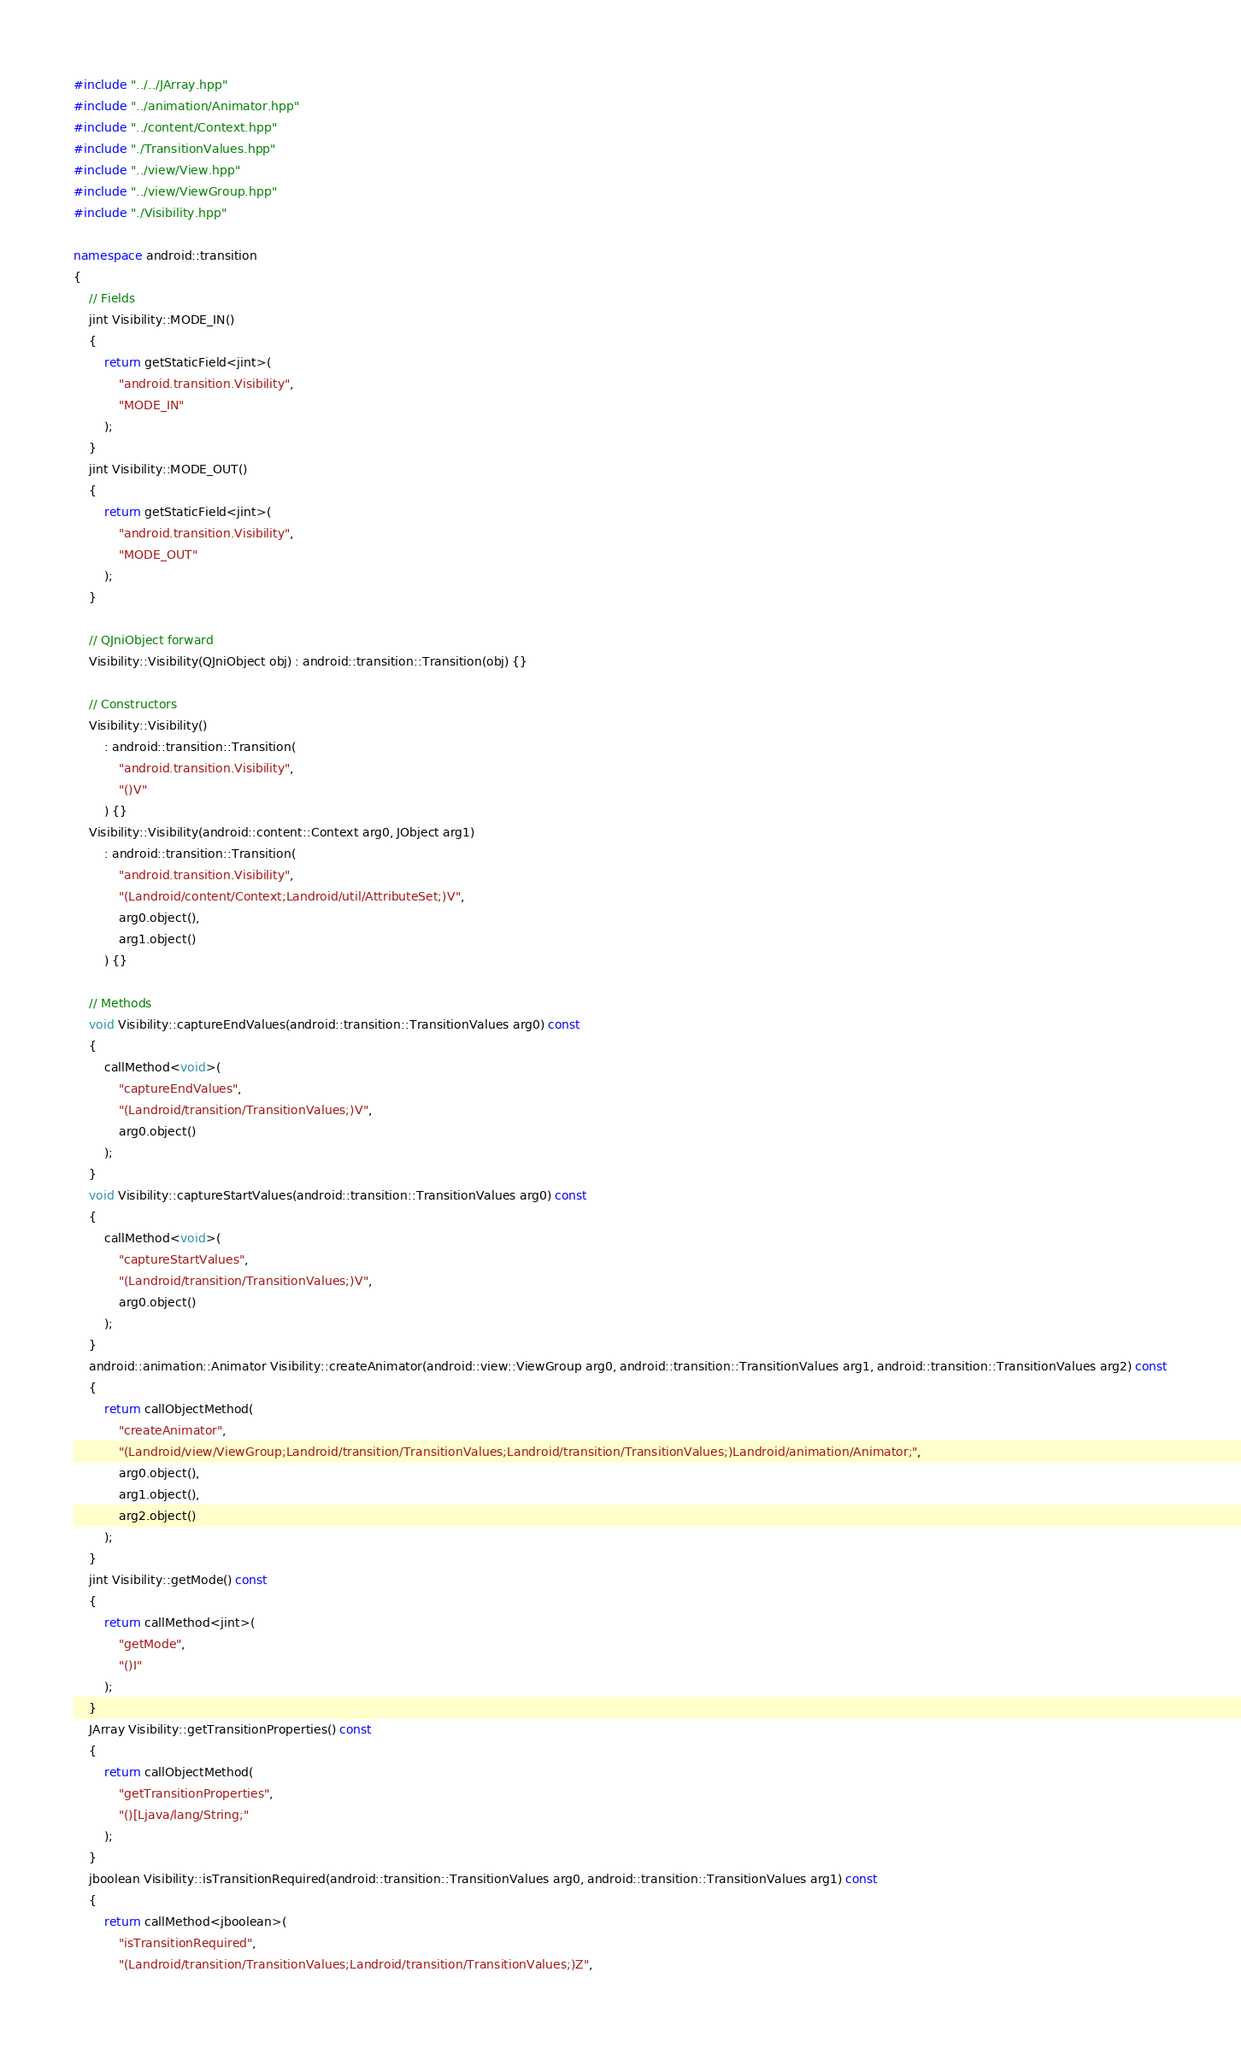<code> <loc_0><loc_0><loc_500><loc_500><_C++_>#include "../../JArray.hpp"
#include "../animation/Animator.hpp"
#include "../content/Context.hpp"
#include "./TransitionValues.hpp"
#include "../view/View.hpp"
#include "../view/ViewGroup.hpp"
#include "./Visibility.hpp"

namespace android::transition
{
	// Fields
	jint Visibility::MODE_IN()
	{
		return getStaticField<jint>(
			"android.transition.Visibility",
			"MODE_IN"
		);
	}
	jint Visibility::MODE_OUT()
	{
		return getStaticField<jint>(
			"android.transition.Visibility",
			"MODE_OUT"
		);
	}
	
	// QJniObject forward
	Visibility::Visibility(QJniObject obj) : android::transition::Transition(obj) {}
	
	// Constructors
	Visibility::Visibility()
		: android::transition::Transition(
			"android.transition.Visibility",
			"()V"
		) {}
	Visibility::Visibility(android::content::Context arg0, JObject arg1)
		: android::transition::Transition(
			"android.transition.Visibility",
			"(Landroid/content/Context;Landroid/util/AttributeSet;)V",
			arg0.object(),
			arg1.object()
		) {}
	
	// Methods
	void Visibility::captureEndValues(android::transition::TransitionValues arg0) const
	{
		callMethod<void>(
			"captureEndValues",
			"(Landroid/transition/TransitionValues;)V",
			arg0.object()
		);
	}
	void Visibility::captureStartValues(android::transition::TransitionValues arg0) const
	{
		callMethod<void>(
			"captureStartValues",
			"(Landroid/transition/TransitionValues;)V",
			arg0.object()
		);
	}
	android::animation::Animator Visibility::createAnimator(android::view::ViewGroup arg0, android::transition::TransitionValues arg1, android::transition::TransitionValues arg2) const
	{
		return callObjectMethod(
			"createAnimator",
			"(Landroid/view/ViewGroup;Landroid/transition/TransitionValues;Landroid/transition/TransitionValues;)Landroid/animation/Animator;",
			arg0.object(),
			arg1.object(),
			arg2.object()
		);
	}
	jint Visibility::getMode() const
	{
		return callMethod<jint>(
			"getMode",
			"()I"
		);
	}
	JArray Visibility::getTransitionProperties() const
	{
		return callObjectMethod(
			"getTransitionProperties",
			"()[Ljava/lang/String;"
		);
	}
	jboolean Visibility::isTransitionRequired(android::transition::TransitionValues arg0, android::transition::TransitionValues arg1) const
	{
		return callMethod<jboolean>(
			"isTransitionRequired",
			"(Landroid/transition/TransitionValues;Landroid/transition/TransitionValues;)Z",</code> 